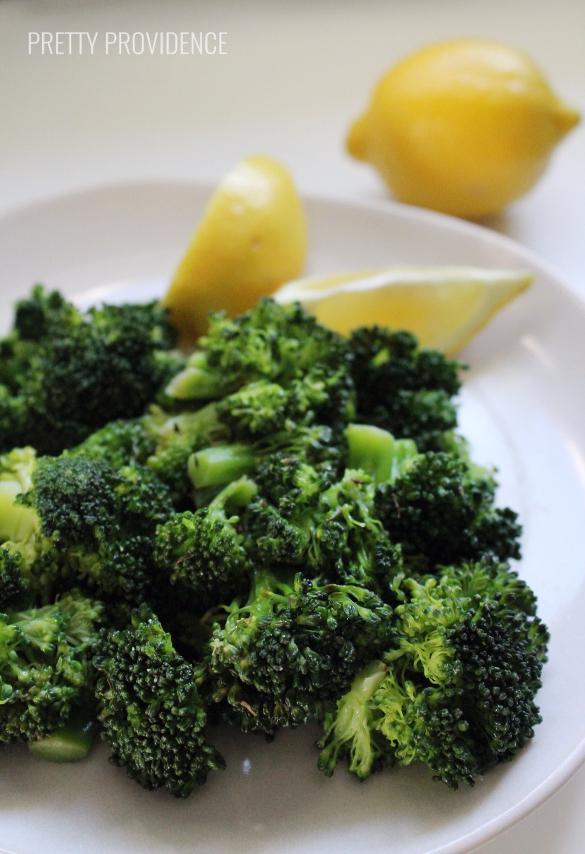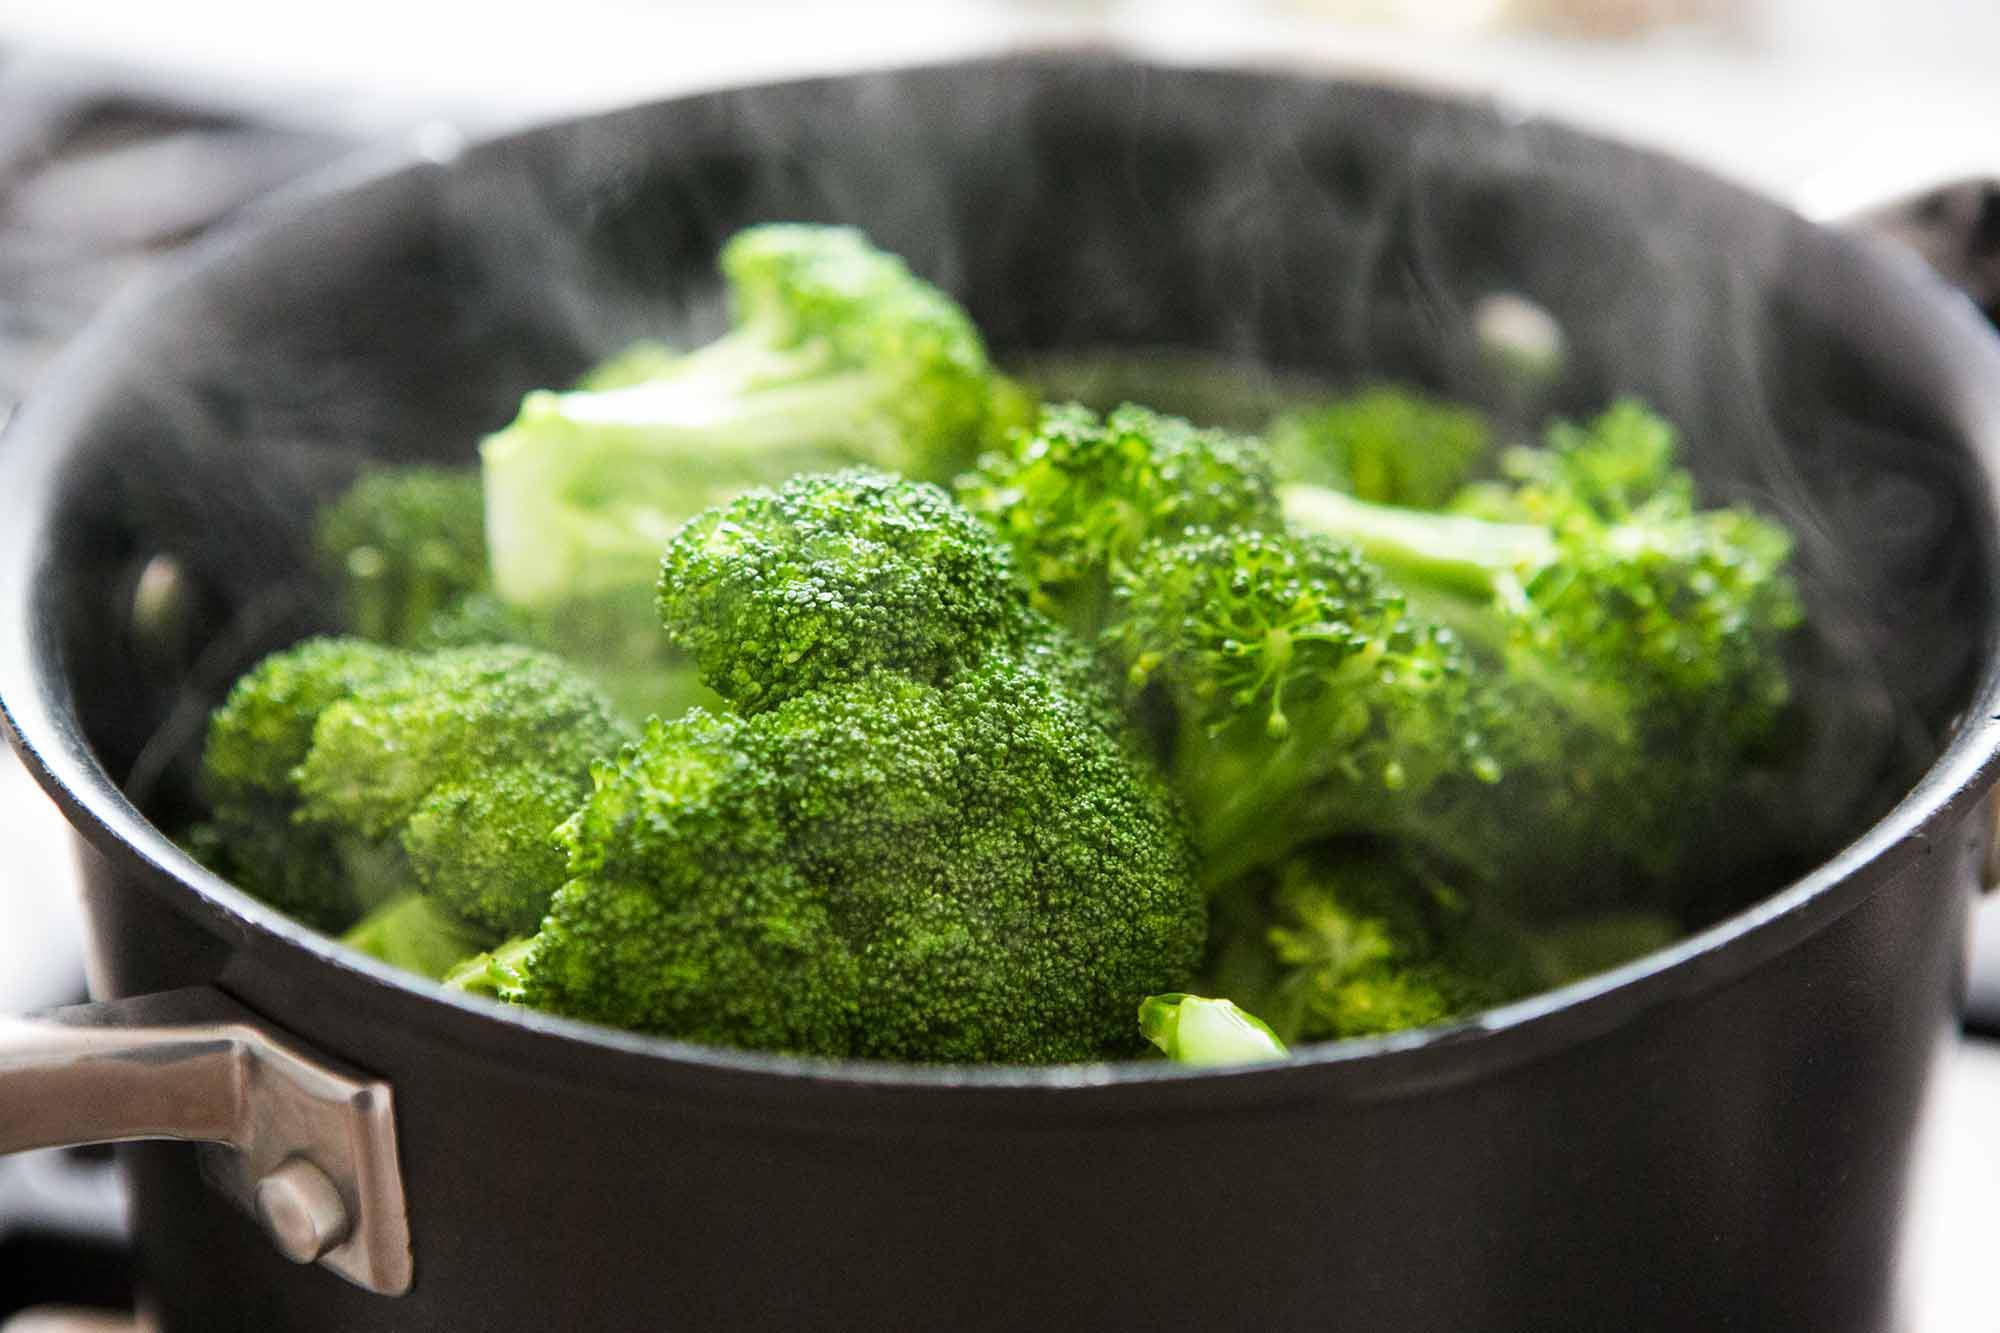The first image is the image on the left, the second image is the image on the right. Considering the images on both sides, is "The left and right image contains the same number of white plates with broccoli." valid? Answer yes or no. No. The first image is the image on the left, the second image is the image on the right. Considering the images on both sides, is "In one image, broccoli florets are being steamed in a metal pot." valid? Answer yes or no. Yes. 